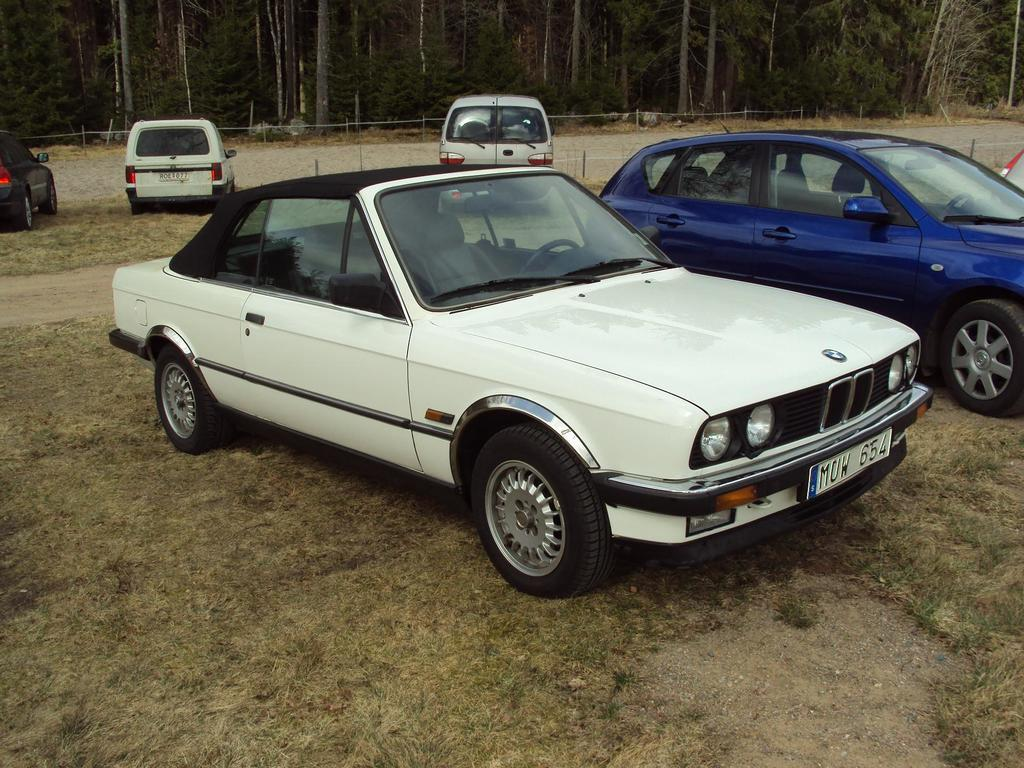What can be seen on the ground in the image? There are vehicles on the ground in the image. Can you describe the color of the cars on the ground? The cars on the ground are blue and white. What type of pathway is visible in the image? There is a road visible in the image. What can be seen in the distance in the image? There are trees in the background of the image. What type of feeling is the birthday party company experiencing in the image? There is no indication of a birthday party or a company in the image, so it is not possible to determine any feelings or emotions. 